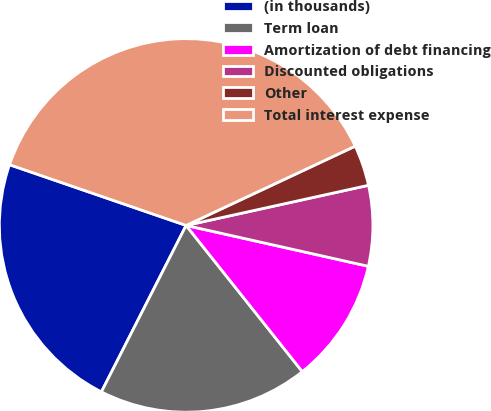Convert chart to OTSL. <chart><loc_0><loc_0><loc_500><loc_500><pie_chart><fcel>(in thousands)<fcel>Term loan<fcel>Amortization of debt financing<fcel>Discounted obligations<fcel>Other<fcel>Total interest expense<nl><fcel>22.78%<fcel>18.18%<fcel>10.8%<fcel>6.96%<fcel>3.53%<fcel>37.75%<nl></chart> 